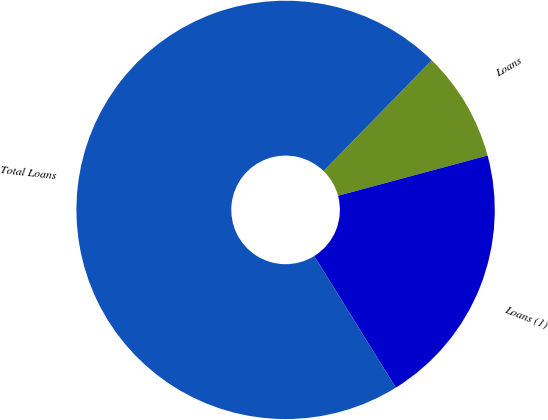Convert chart. <chart><loc_0><loc_0><loc_500><loc_500><pie_chart><fcel>Loans<fcel>Loans (1)<fcel>Total Loans<nl><fcel>8.5%<fcel>20.35%<fcel>71.15%<nl></chart> 